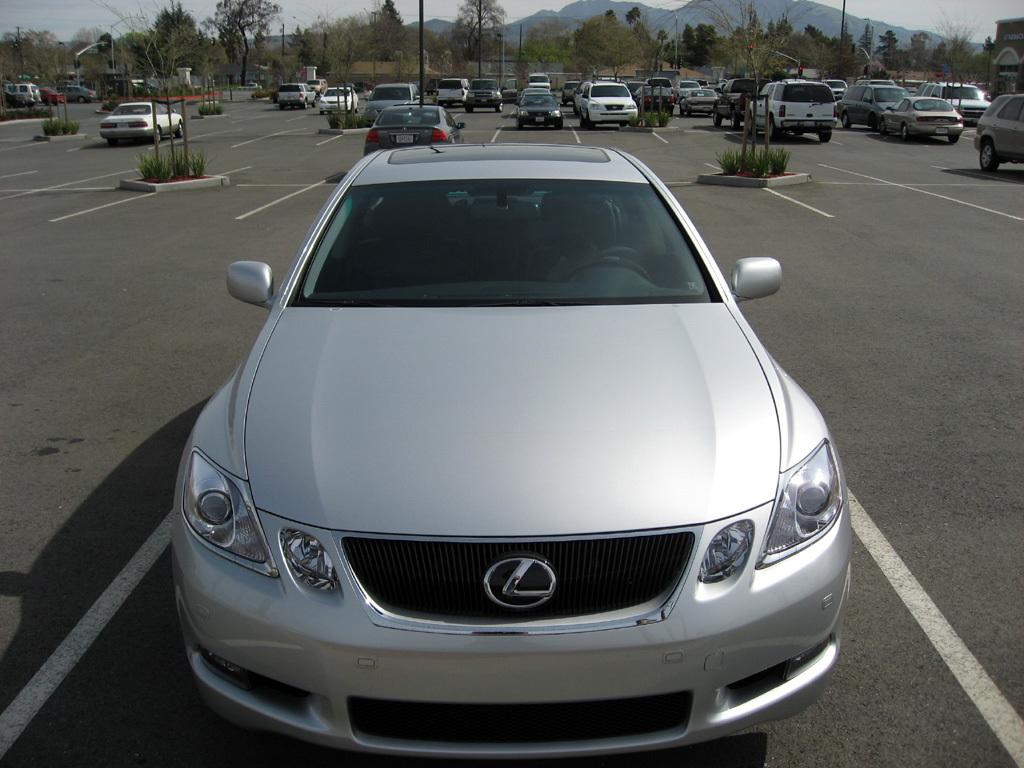What can be seen on the road in the image? There are vehicles on the road in the image. What type of natural elements are present in the image? There are plants, trees, and mountains in the image. Can you describe the rod in the image? Yes, there is a rod in the image. What type of structure is visible in the image? There is a building in the image. What is visible in the background of the image? The sky and mountains are visible in the background of the image. What type of organization is depicted in the image? There is no organization depicted in the image; it features vehicles on the road, plants, trees, a rod, a building, mountains, and the sky. How many clouds are visible in the image? There are no clouds visible in the image. 